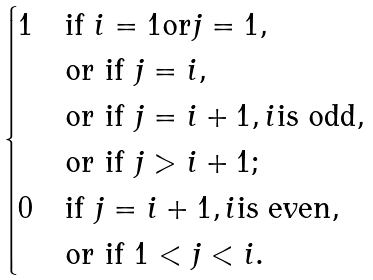Convert formula to latex. <formula><loc_0><loc_0><loc_500><loc_500>\begin{cases} 1 & \text {if } i = 1 \text {or} j = 1 , \\ & \text {or if } j = i , \\ & \text {or if } j = i + 1 , i \text {is odd} , \\ & \text {or if } j > i + 1 ; \\ 0 & \text {if } j = i + 1 , i \text {is even} , \\ & \text {or if } 1 < j < i . \end{cases}</formula> 